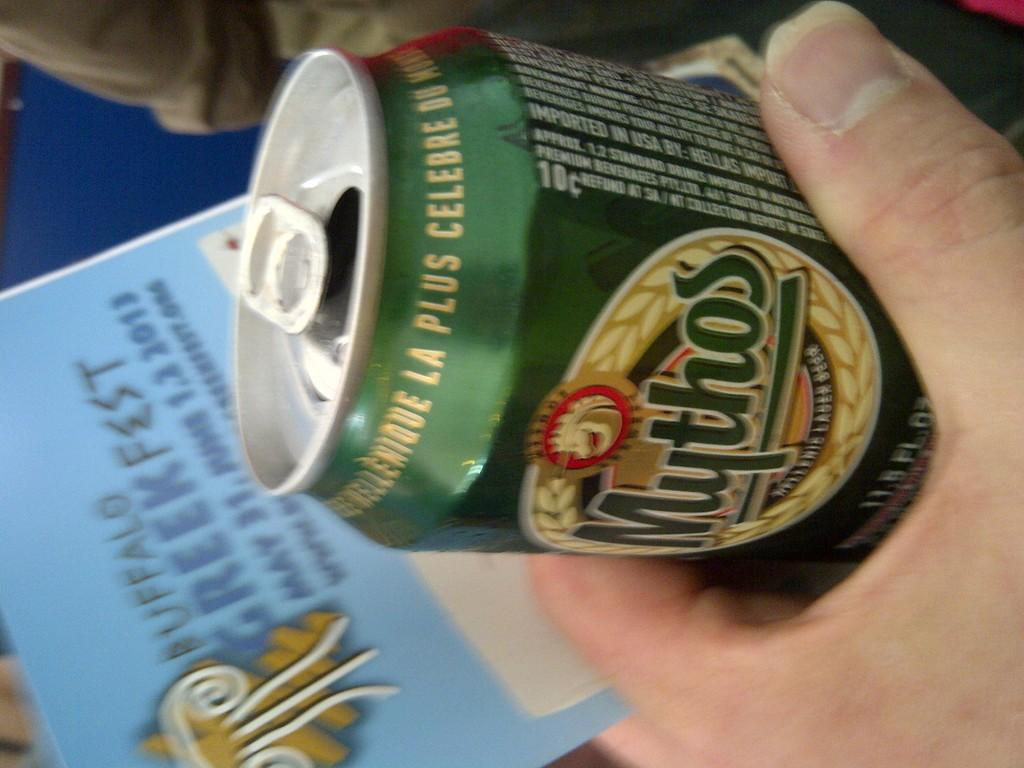<image>
Relay a brief, clear account of the picture shown. Person holding a beer can which says "Mythos". 